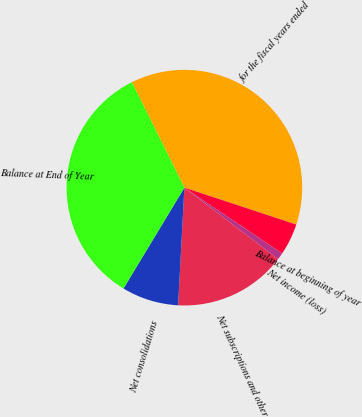Convert chart to OTSL. <chart><loc_0><loc_0><loc_500><loc_500><pie_chart><fcel>for the fiscal years ended<fcel>Balance at beginning of year<fcel>Net income (loss)<fcel>Net subscriptions and other<fcel>Net consolidations<fcel>Balance at End of Year<nl><fcel>37.43%<fcel>4.37%<fcel>0.93%<fcel>15.48%<fcel>7.8%<fcel>33.99%<nl></chart> 